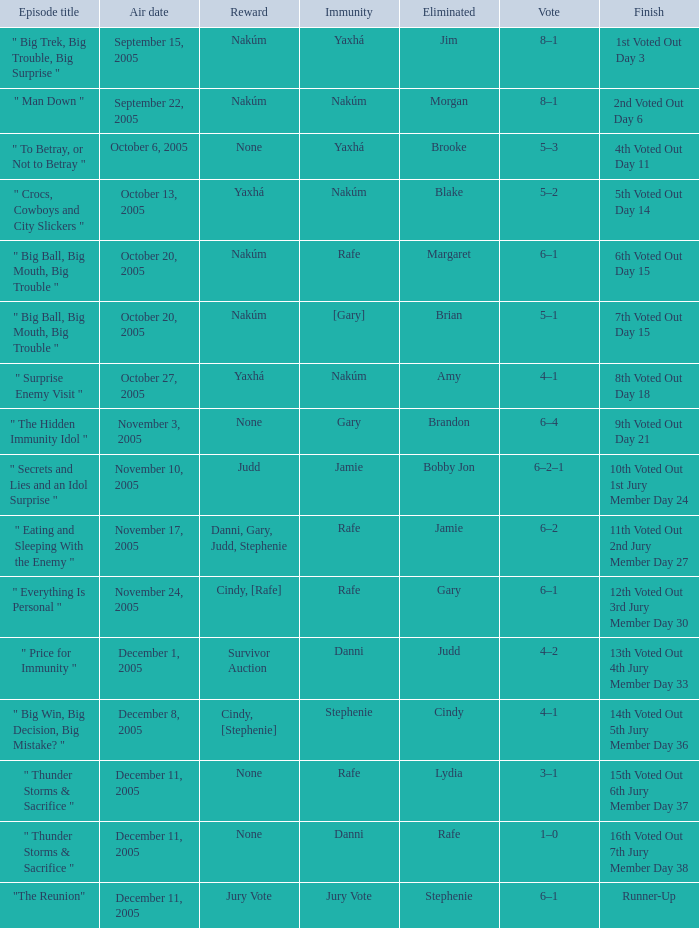What was eliminated on the air date of November 3, 2005? Brandon. 